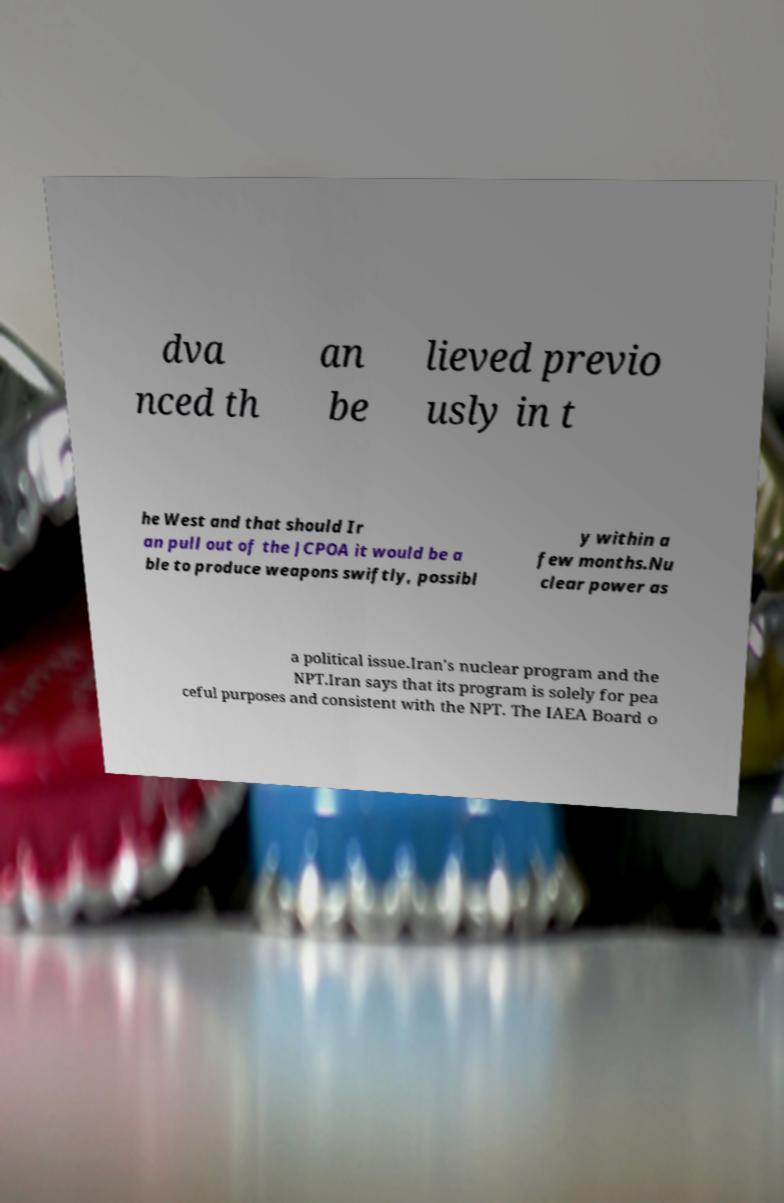Please read and relay the text visible in this image. What does it say? dva nced th an be lieved previo usly in t he West and that should Ir an pull out of the JCPOA it would be a ble to produce weapons swiftly, possibl y within a few months.Nu clear power as a political issue.Iran's nuclear program and the NPT.Iran says that its program is solely for pea ceful purposes and consistent with the NPT. The IAEA Board o 